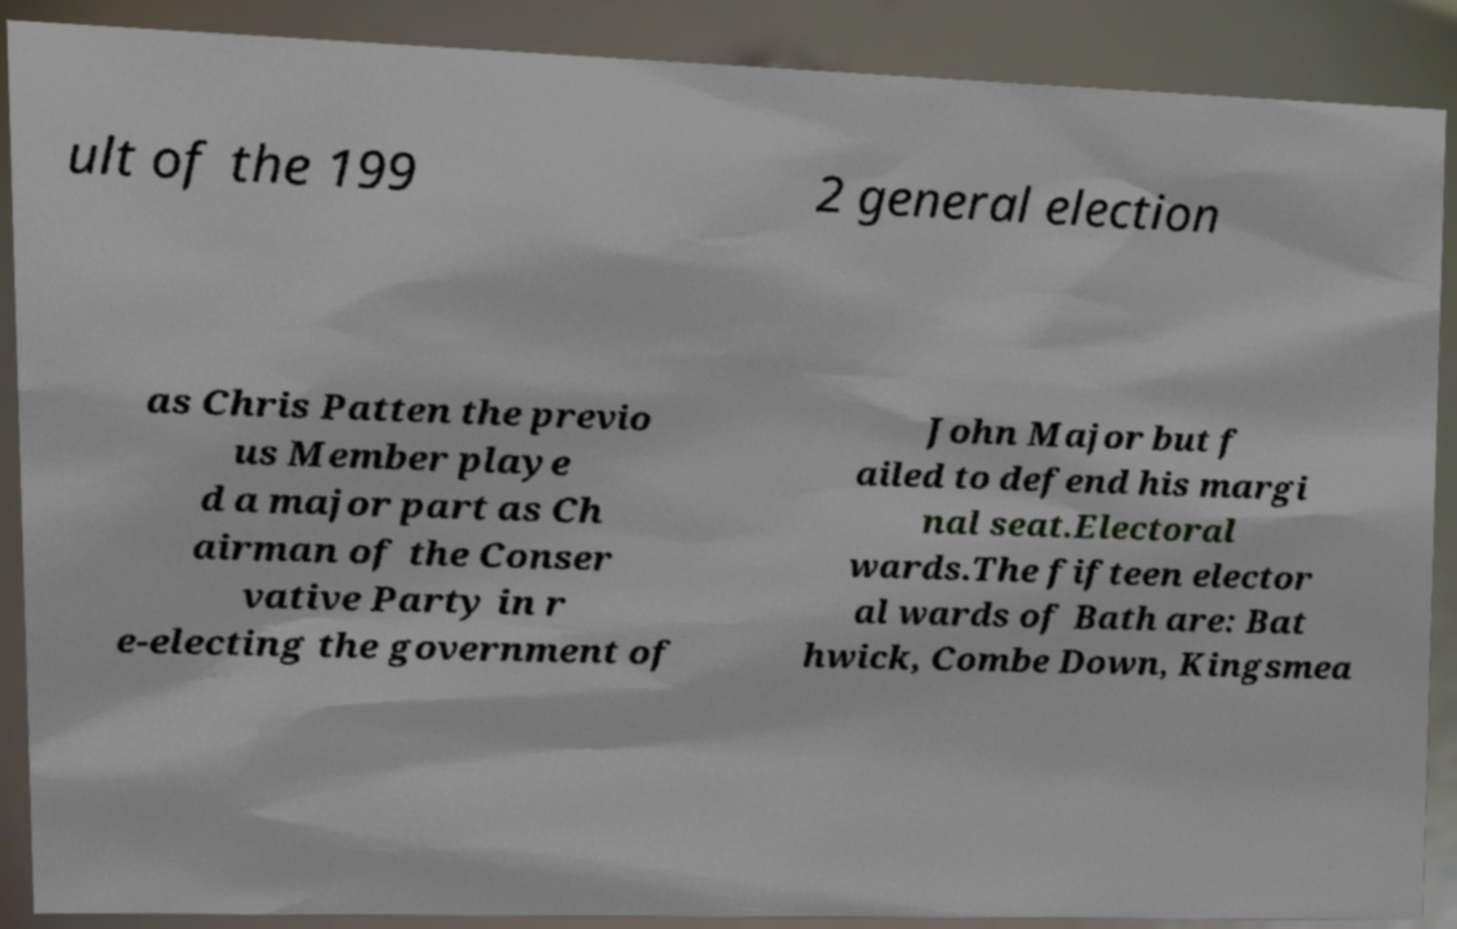Can you read and provide the text displayed in the image?This photo seems to have some interesting text. Can you extract and type it out for me? ult of the 199 2 general election as Chris Patten the previo us Member playe d a major part as Ch airman of the Conser vative Party in r e-electing the government of John Major but f ailed to defend his margi nal seat.Electoral wards.The fifteen elector al wards of Bath are: Bat hwick, Combe Down, Kingsmea 